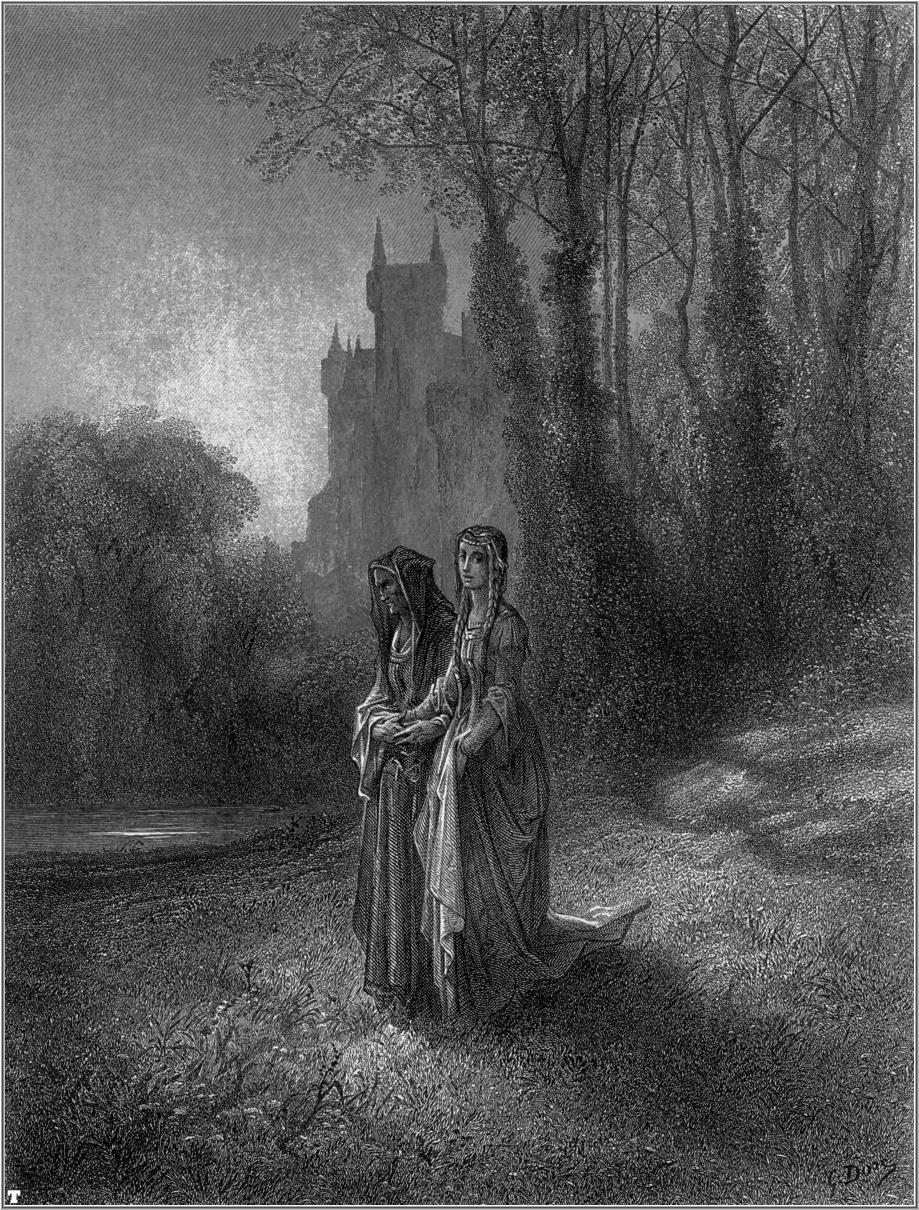Write a detailed description of the given image. This black and white illustration captures a serene moment in a dense forest. Two women, dressed in elaborate medieval gowns with intricate details, wander through the forest path. One woman is carrying a basket that likely contains the day's gathered goods, adding a practical touch to their picturesque journey. Their faces reflect a peaceful, contemplative mood, as if they are engaged in deep conversation or sharing a silent reflection. The art style is realistic, emphasizing the fine details in their dresses, the leaves, and the texture of the ground. In the distance, the silhouette of a majestic castle rises with its towering spires piercing the sky, lending a sense of mystery and grandiosity to the imagery. The vertical composition of the illustration accentuates the height of the trees and the imposing presence of the castle. Despite the absence of colors, the rich textures and detailed shading bring the scene to life, creating a compelling narrative that speaks of a medieval era filled with simplicity and grace. 